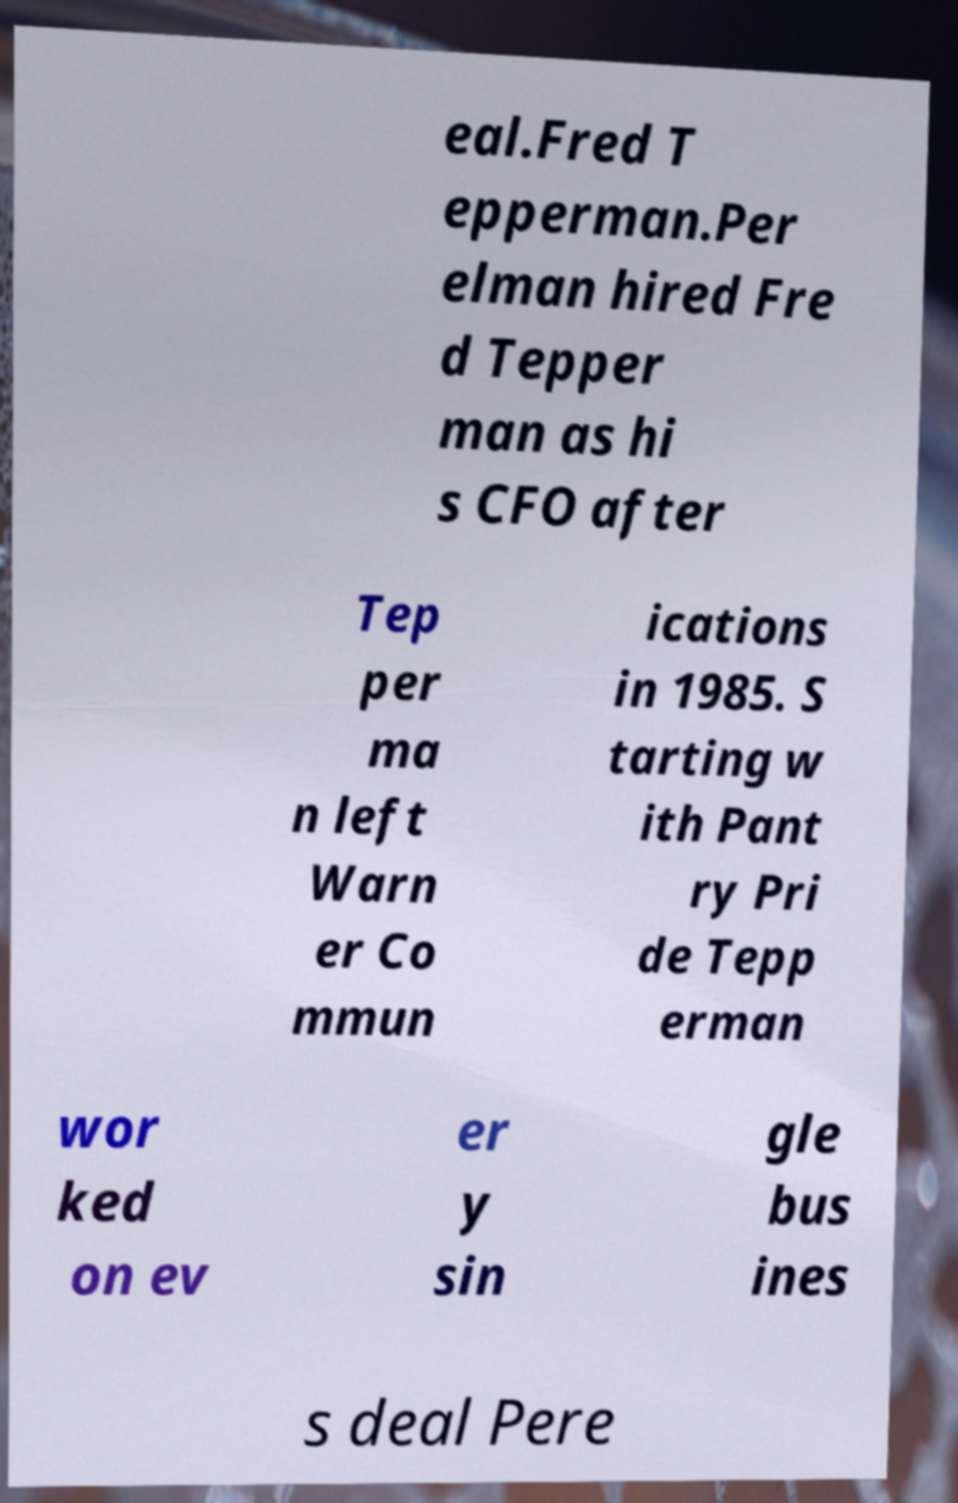I need the written content from this picture converted into text. Can you do that? eal.Fred T epperman.Per elman hired Fre d Tepper man as hi s CFO after Tep per ma n left Warn er Co mmun ications in 1985. S tarting w ith Pant ry Pri de Tepp erman wor ked on ev er y sin gle bus ines s deal Pere 